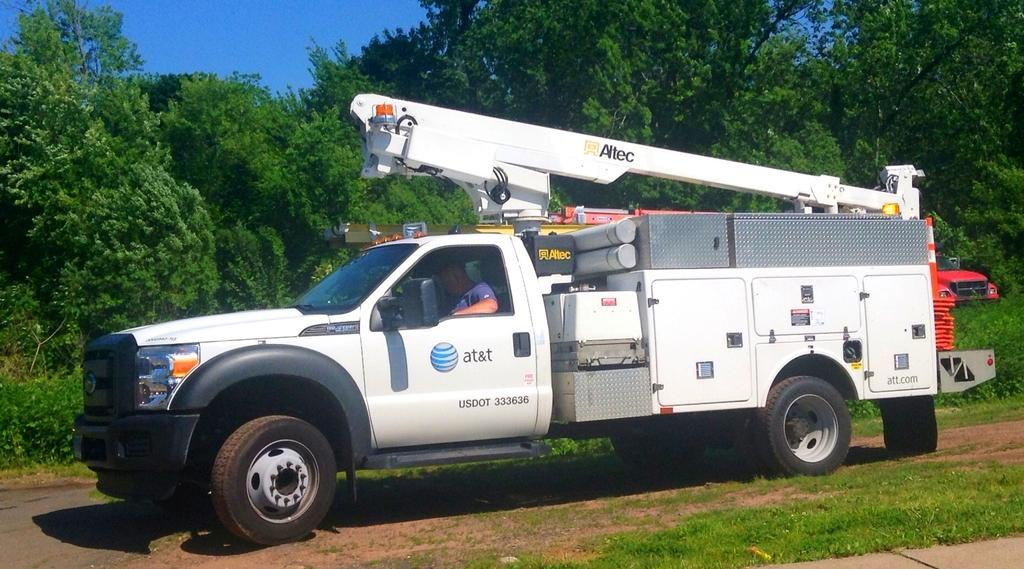What is on the ground in the image? There is a vehicle on the ground in the image. Who is inside the vehicle? There is a person sitting in the vehicle. What can be seen in the distance behind the vehicle? There are many trees and another vehicle visible in the background. What part of the natural environment is visible in the image? The sky is visible in the background of the image. Can you see a woman using a spoon to swim in the image? There is no woman using a spoon to swim in the image. 